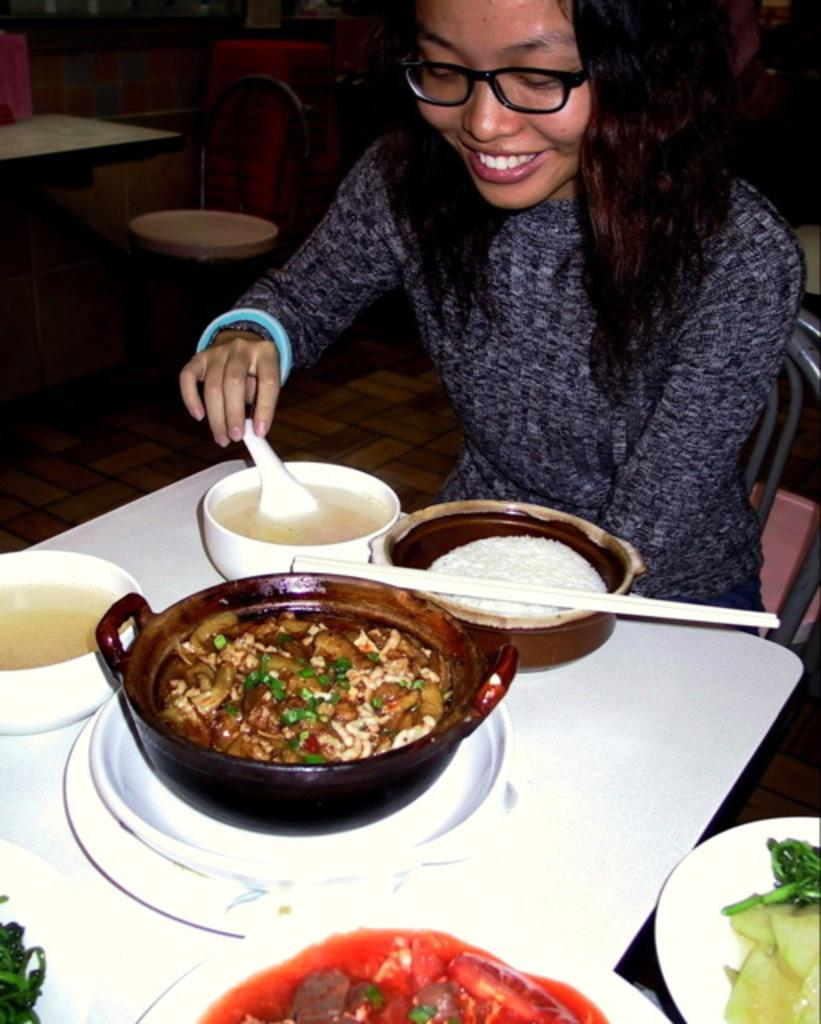What is the person in the image doing? The person is sitting on a chair in the image. What can be seen on the tables in the image? There is food on plates and soup in bowls on the tables in the image. What type of furniture is present in the image? There are tables and chairs in the image. How many ladybugs are crawling on the person's arm in the image? There are no ladybugs present in the image. What is the title of the image? The image does not have a title. 